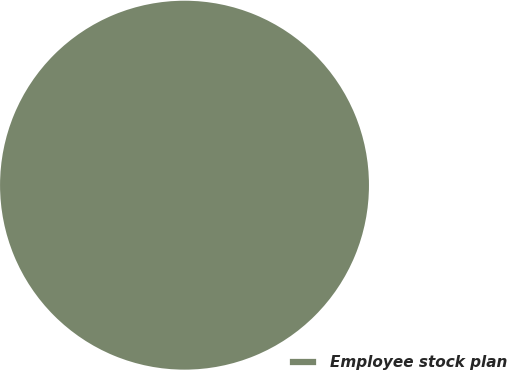Convert chart. <chart><loc_0><loc_0><loc_500><loc_500><pie_chart><fcel>Employee stock plan<nl><fcel>100.0%<nl></chart> 